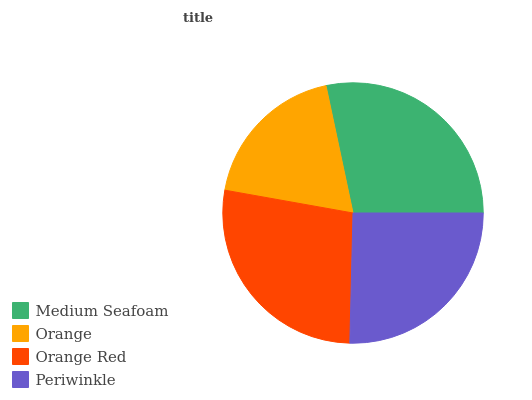Is Orange the minimum?
Answer yes or no. Yes. Is Medium Seafoam the maximum?
Answer yes or no. Yes. Is Orange Red the minimum?
Answer yes or no. No. Is Orange Red the maximum?
Answer yes or no. No. Is Orange Red greater than Orange?
Answer yes or no. Yes. Is Orange less than Orange Red?
Answer yes or no. Yes. Is Orange greater than Orange Red?
Answer yes or no. No. Is Orange Red less than Orange?
Answer yes or no. No. Is Orange Red the high median?
Answer yes or no. Yes. Is Periwinkle the low median?
Answer yes or no. Yes. Is Medium Seafoam the high median?
Answer yes or no. No. Is Orange Red the low median?
Answer yes or no. No. 